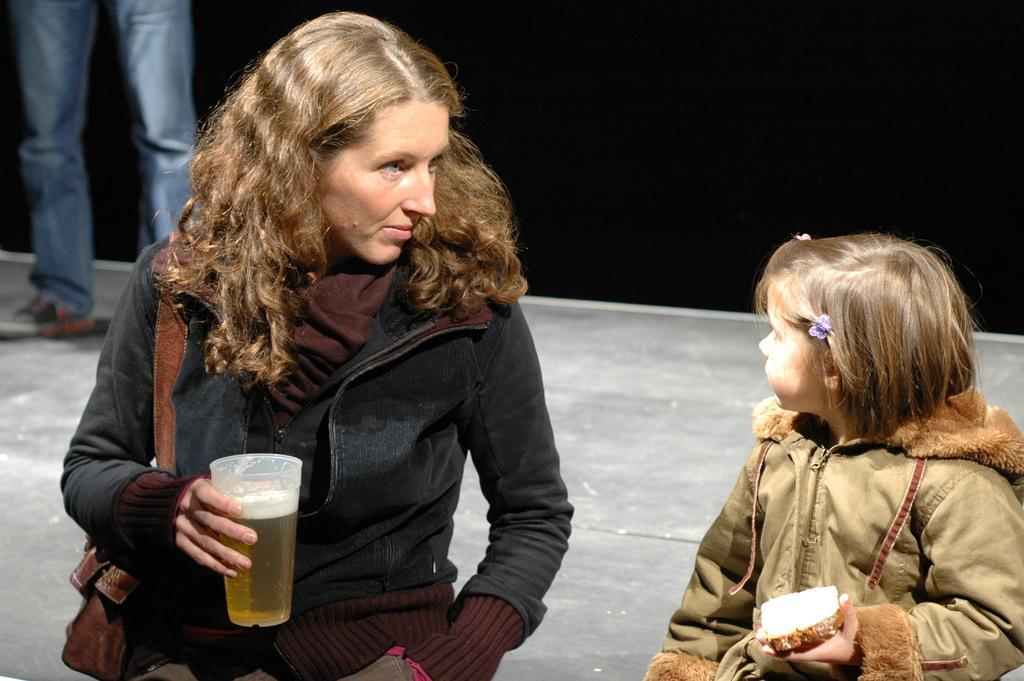Who is present in the image? There is a woman and a girl in the image. What is the woman holding in the image? The woman is holding a glass in the image. What additional object can be seen in the image? There is a bag in the image. Can you see a dog performing an operation in the image? No, there is no dog or operation present in the image. 